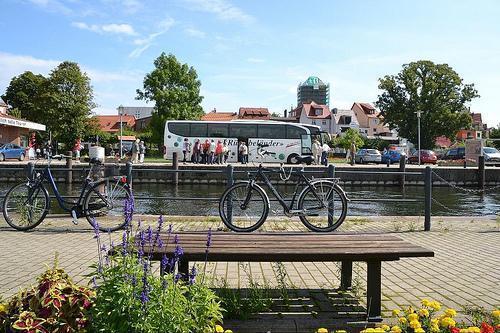How many bicycles are in this photo?
Give a very brief answer. 2. 